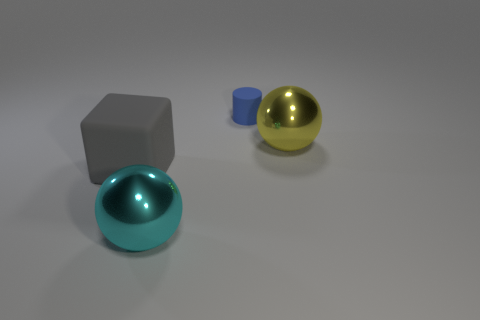Add 2 red rubber blocks. How many objects exist? 6 Subtract all cubes. How many objects are left? 3 Subtract all gray blocks. Subtract all large metal balls. How many objects are left? 1 Add 1 large yellow balls. How many large yellow balls are left? 2 Add 4 large cyan shiny things. How many large cyan shiny things exist? 5 Subtract 0 gray balls. How many objects are left? 4 